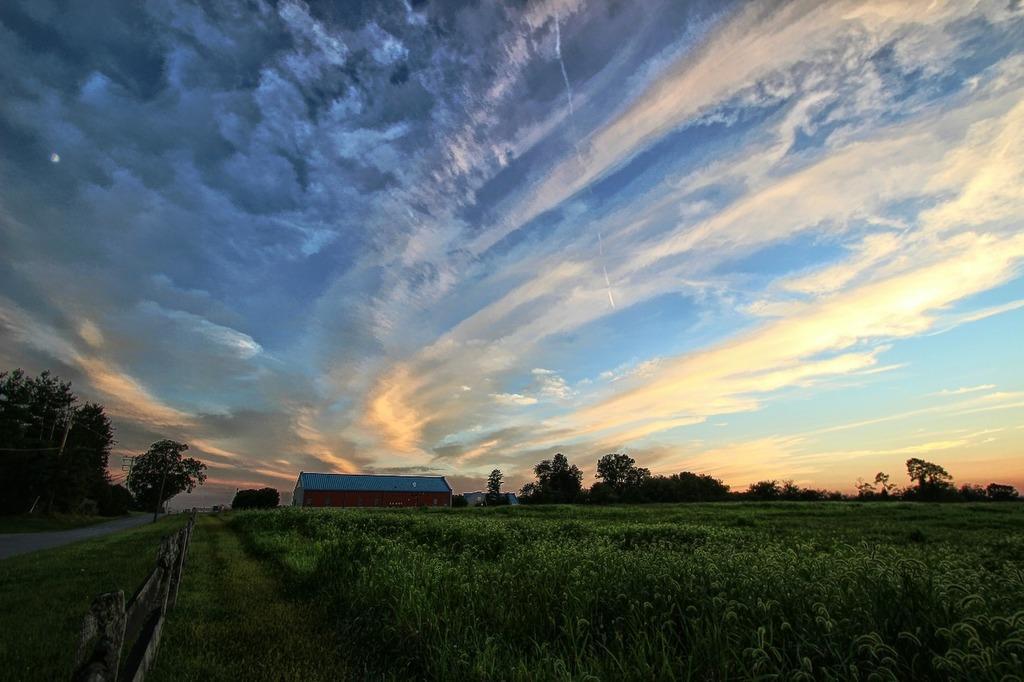How would you summarize this image in a sentence or two? In this picture there is a green grass and there is a wooden fence in the left corner and there is a house and trees in the background and the sky is a bit cloudy. 